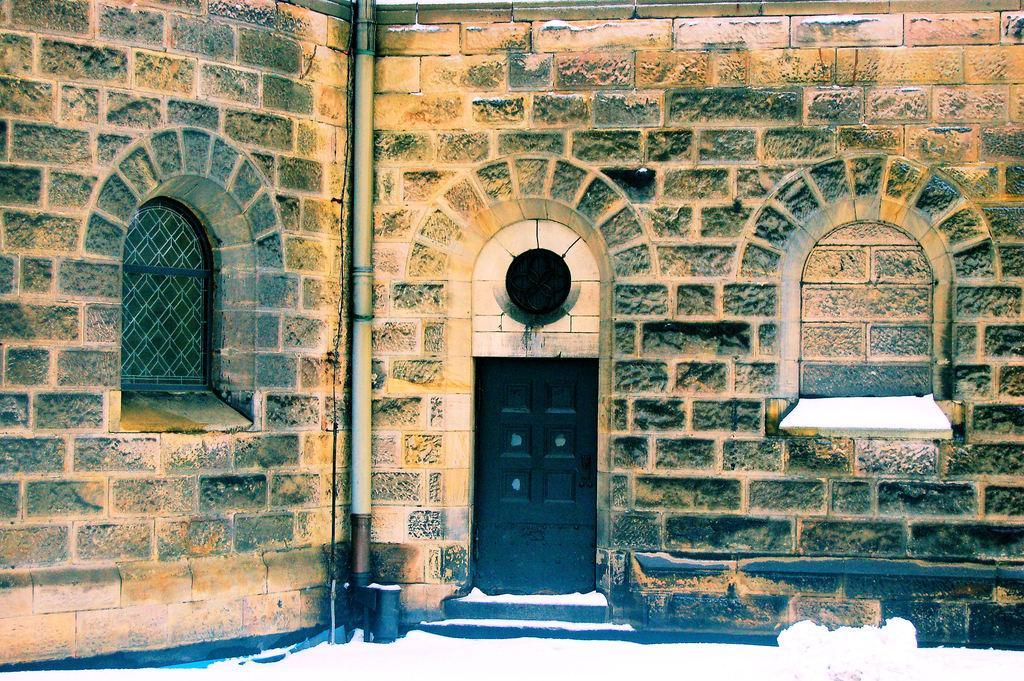In one or two sentences, can you explain what this image depicts? In this picture we can see wall, windows, pole, door and snow. 